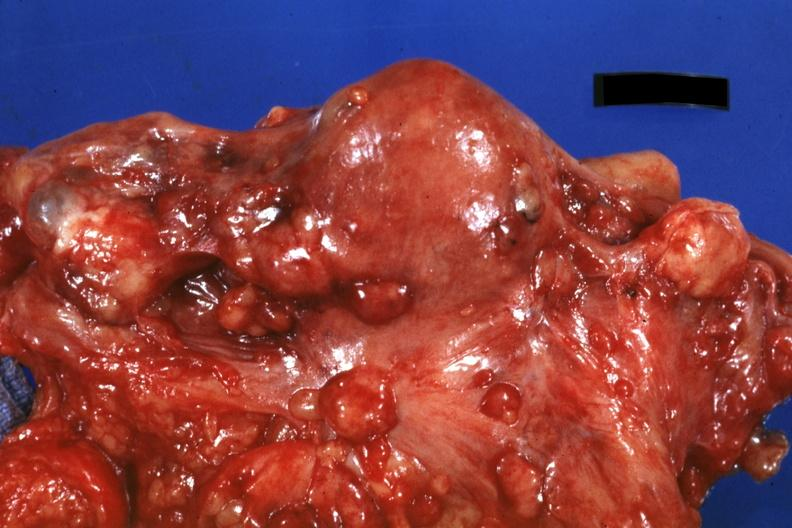s abdomen present?
Answer the question using a single word or phrase. Yes 